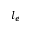<formula> <loc_0><loc_0><loc_500><loc_500>l _ { e }</formula> 